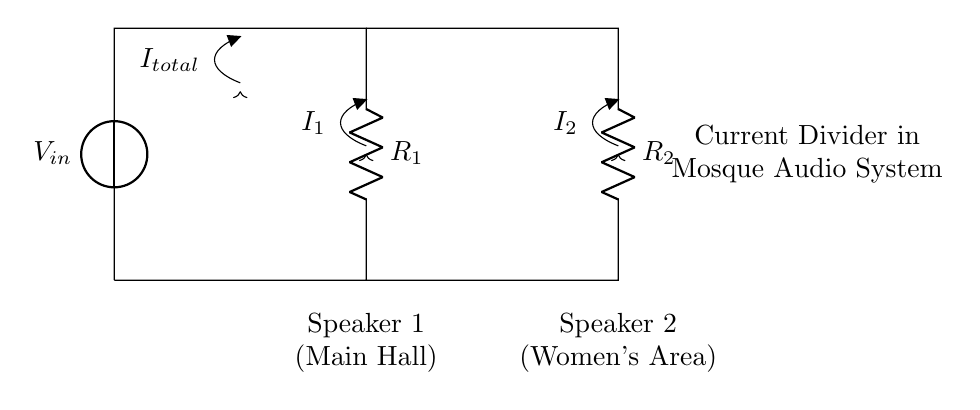What is the total current entering the circuit? The total current entering the circuit is labeled as "I_total" in the diagram, which represents the sum of the currents flowing through both resistors.
Answer: I_total What type of circuit is shown here? The circuit represents a current divider, where total current is divided between two parallel paths (in this case, the two speakers).
Answer: Current divider What are the components used in this circuit? The primary components shown in the circuit are two resistors (R1 and R2) and a voltage source (V_in), which collectively make up the audio system.
Answer: R1, R2, V_in Which speaker has the higher output current? According to the current divider principle, the speaker representing the smaller resistor will have the higher current. Since we do not have the values for R1 and R2, we can’t determine which one has higher output without comparing their resistances.
Answer: Depends on R1 and R2 How many speakers are connected in this audio system? The diagram clearly shows two speakers connected in parallel within the audio system.
Answer: Two speakers What does the label “I1” represent? The label “I1” in the diagram indicates the current flowing through R1 and into Speaker 1, which is a part of the current divider circuit.
Answer: Current through R1 